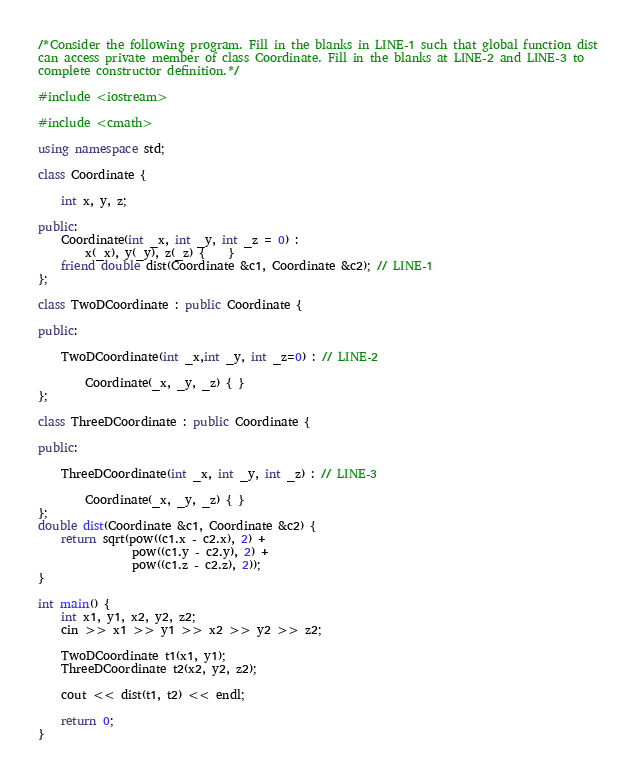<code> <loc_0><loc_0><loc_500><loc_500><_C++_>/*Consider the following program. Fill in the blanks in LINE-1 such that global function dist
can access private member of class Coordinate. Fill in the blanks at LINE-2 and LINE-3 to
complete constructor definition.*/

#include <iostream>

#include <cmath>

using namespace std;

class Coordinate {

    int x, y, z;

public:
    Coordinate(int _x, int _y, int _z = 0) : 
        x(_x), y(_y), z(_z) {    }
    friend double dist(Coordinate &c1, Coordinate &c2); // LINE-1
};

class TwoDCoordinate : public Coordinate {

public:

    TwoDCoordinate(int _x,int _y, int _z=0) : // LINE-2

        Coordinate(_x, _y, _z) { }        
};

class ThreeDCoordinate : public Coordinate {

public:

    ThreeDCoordinate(int _x, int _y, int _z) : // LINE-3

        Coordinate(_x, _y, _z) { } 
};
double dist(Coordinate &c1, Coordinate &c2) {
    return sqrt(pow((c1.x - c2.x), 2) + 
                pow((c1.y - c2.y), 2) + 
                pow((c1.z - c2.z), 2));
}

int main() {
    int x1, y1, x2, y2, z2;
    cin >> x1 >> y1 >> x2 >> y2 >> z2;

    TwoDCoordinate t1(x1, y1);
    ThreeDCoordinate t2(x2, y2, z2);

    cout << dist(t1, t2) << endl;

    return 0;
}
</code> 